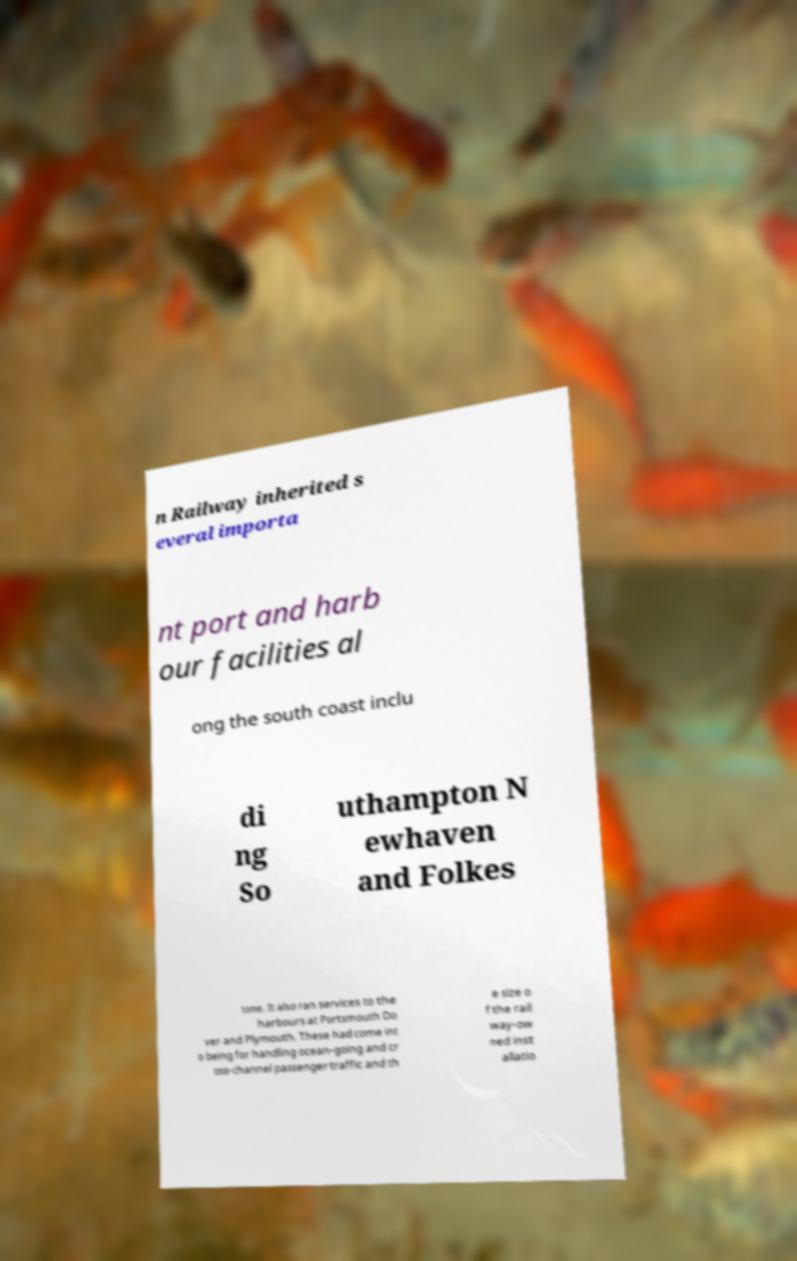Please read and relay the text visible in this image. What does it say? n Railway inherited s everal importa nt port and harb our facilities al ong the south coast inclu di ng So uthampton N ewhaven and Folkes tone. It also ran services to the harbours at Portsmouth Do ver and Plymouth. These had come int o being for handling ocean-going and cr oss-channel passenger traffic and th e size o f the rail way-ow ned inst allatio 